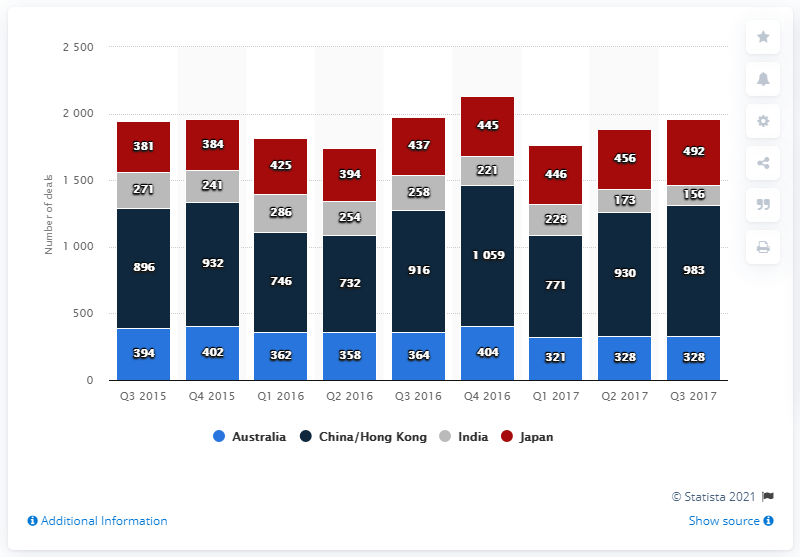Identify some key points in this picture. There were 983 merger and acquisition deals in China and Hong Kong during the third quarter of 2017. 